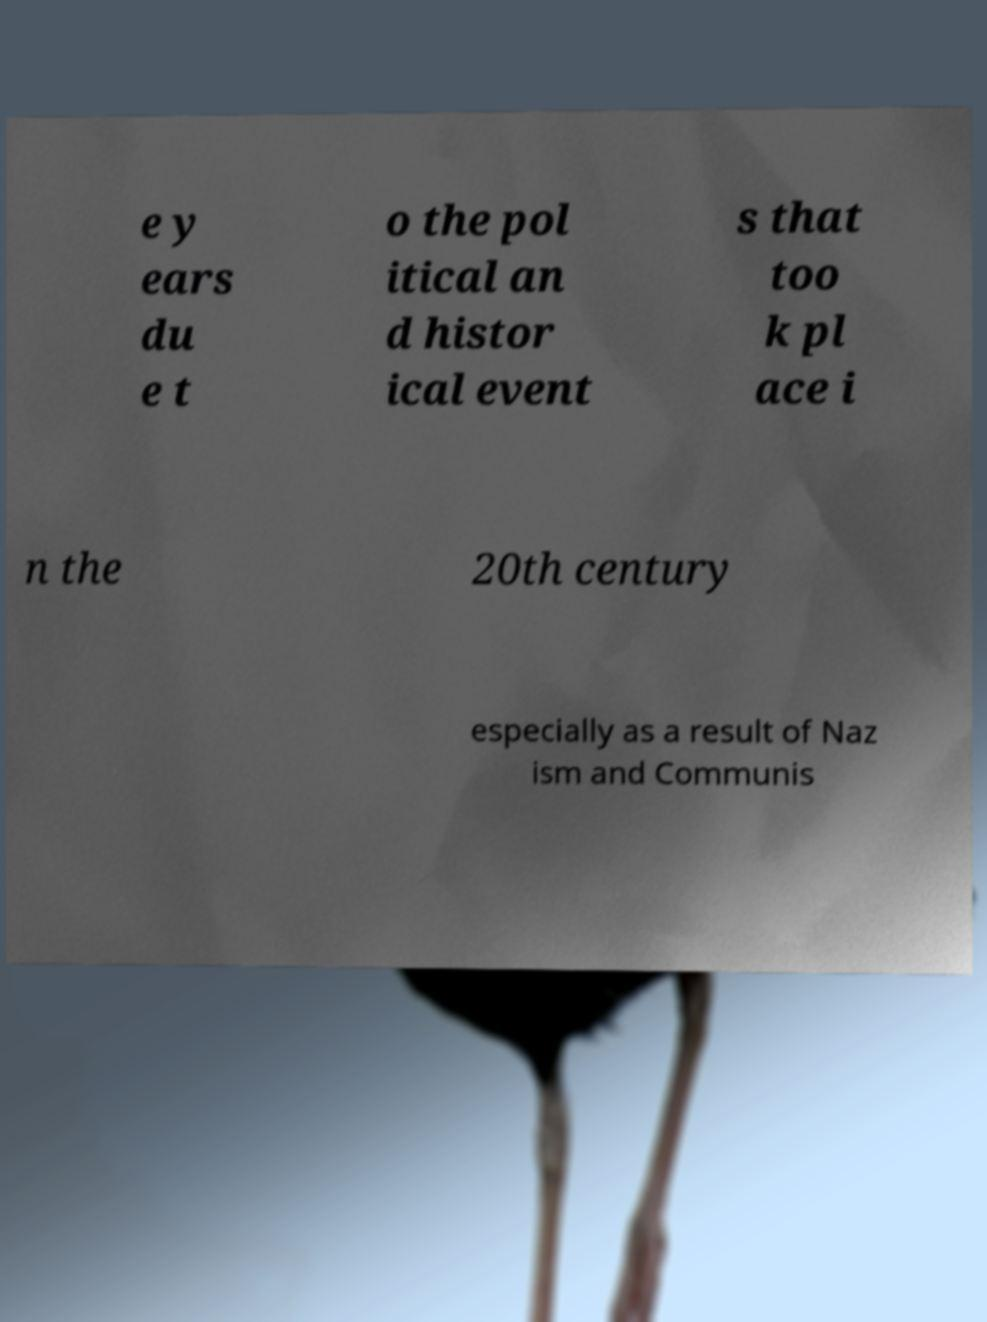I need the written content from this picture converted into text. Can you do that? e y ears du e t o the pol itical an d histor ical event s that too k pl ace i n the 20th century especially as a result of Naz ism and Communis 